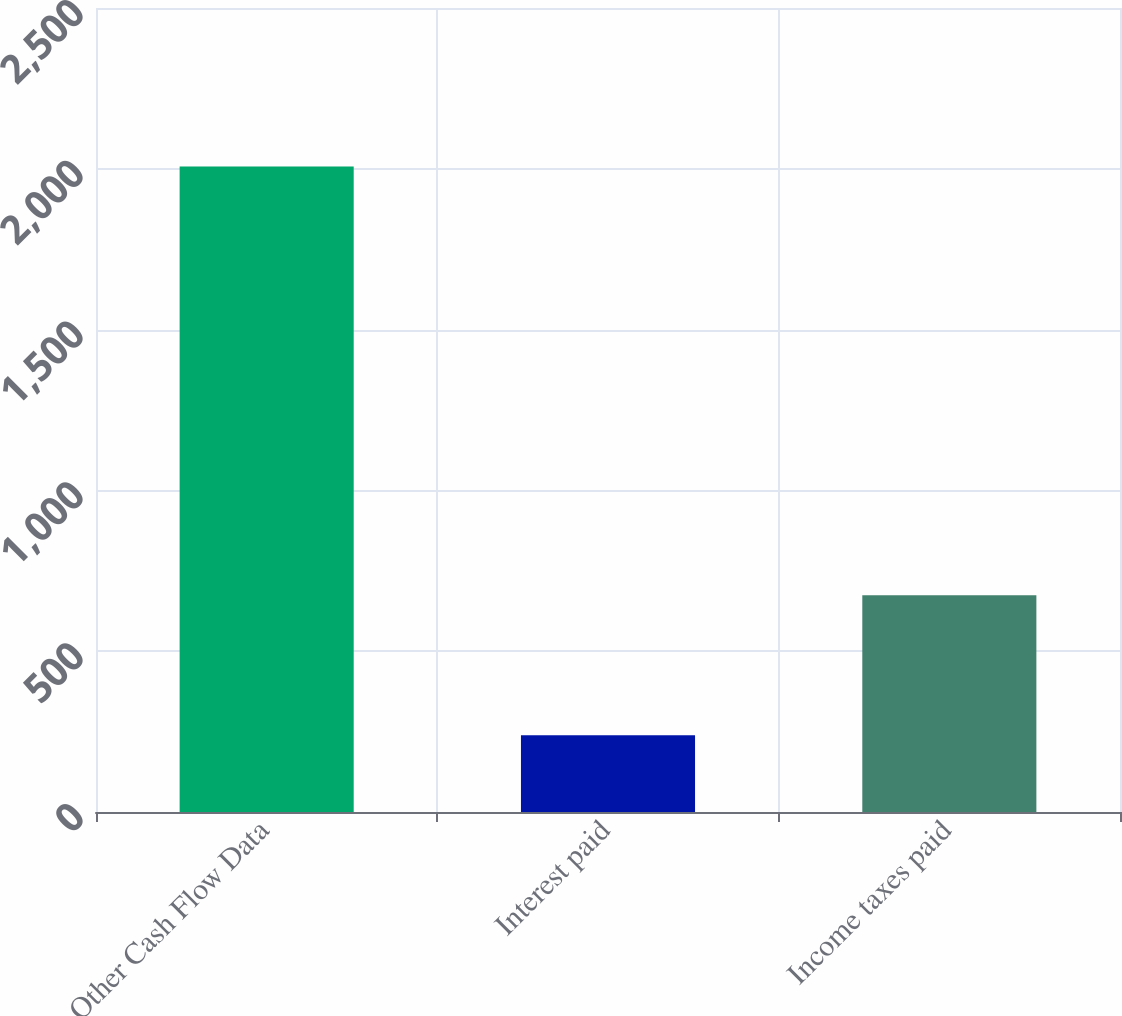<chart> <loc_0><loc_0><loc_500><loc_500><bar_chart><fcel>Other Cash Flow Data<fcel>Interest paid<fcel>Income taxes paid<nl><fcel>2007<fcel>239<fcel>674<nl></chart> 